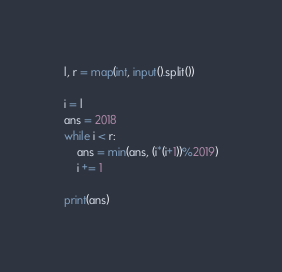<code> <loc_0><loc_0><loc_500><loc_500><_Python_>l, r = map(int, input().split())

i = l
ans = 2018
while i < r:
    ans = min(ans, (i*(i+1))%2019)
    i += 1

print(ans)</code> 